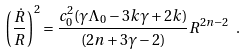<formula> <loc_0><loc_0><loc_500><loc_500>\left ( \frac { \dot { R } } { R } \right ) ^ { 2 } = \frac { c _ { 0 } ^ { 2 } ( \gamma \Lambda _ { 0 } - 3 k \gamma + 2 k ) } { ( 2 n + 3 \gamma - 2 ) } R ^ { 2 n - 2 } \ .</formula> 